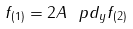Convert formula to latex. <formula><loc_0><loc_0><loc_500><loc_500>f _ { ( 1 ) } = 2 A \, \ p d _ { y } f _ { ( 2 ) }</formula> 